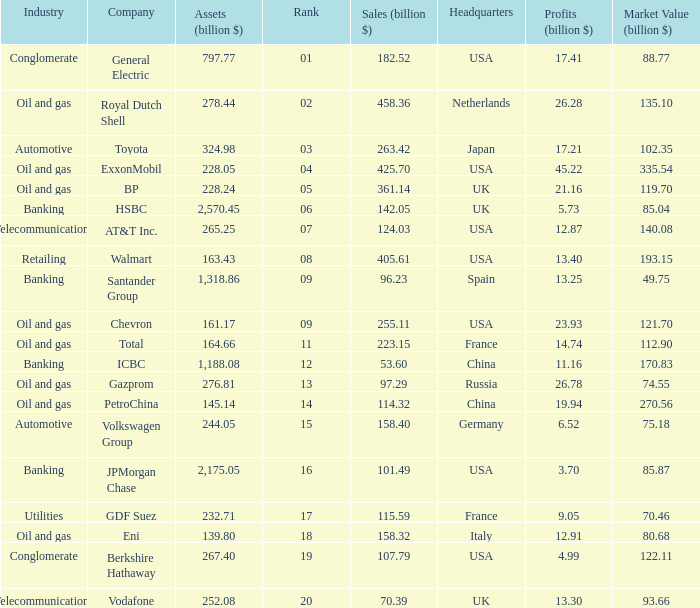Name the lowest Market Value (billion $) which has Assets (billion $) larger than 276.81, and a Company of toyota, and Profits (billion $) larger than 17.21? None. 